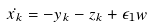Convert formula to latex. <formula><loc_0><loc_0><loc_500><loc_500>\dot { x _ { k } } = - y _ { k } - z _ { k } + \epsilon _ { 1 } w</formula> 